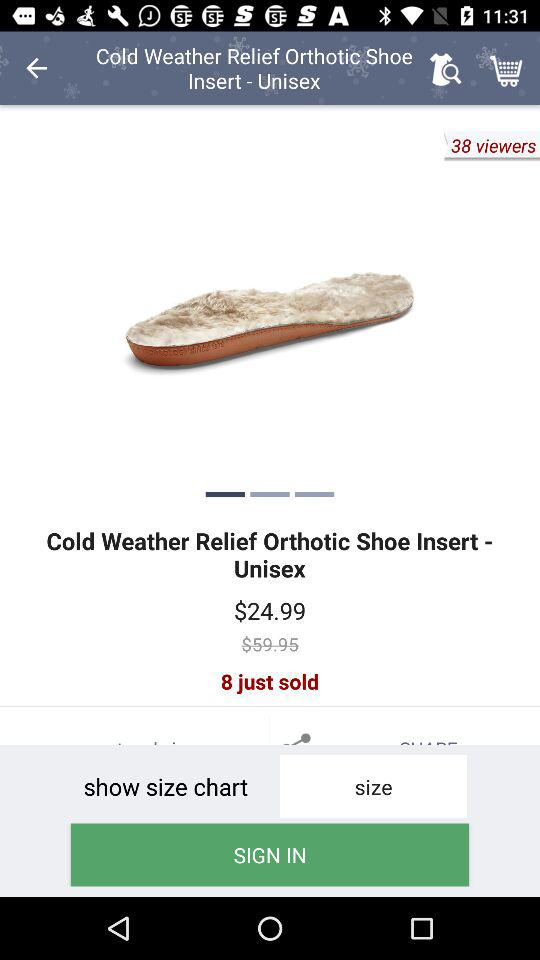How many viewers are there for the product? There are 38 viewers for the product. 